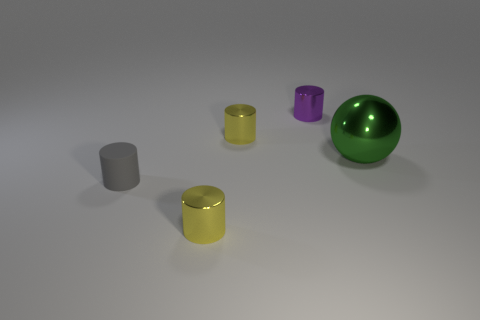There is a purple thing that is the same material as the large ball; what size is it?
Your answer should be very brief. Small. Are there any other things that are the same color as the large metallic thing?
Make the answer very short. No. The small yellow cylinder that is in front of the green metallic sphere in front of the tiny yellow metallic object behind the gray rubber cylinder is made of what material?
Keep it short and to the point. Metal. How many rubber objects are either cyan objects or gray objects?
Offer a very short reply. 1. Is the matte cylinder the same color as the large shiny sphere?
Ensure brevity in your answer.  No. Is there anything else that is the same material as the small gray object?
Provide a succinct answer. No. What number of objects are rubber things or yellow things behind the big green metallic thing?
Make the answer very short. 2. There is a metal thing that is in front of the gray thing; is it the same size as the small purple object?
Offer a very short reply. Yes. How many other objects are the same shape as the gray matte thing?
Make the answer very short. 3. How many red objects are large balls or rubber cylinders?
Your answer should be compact. 0. 